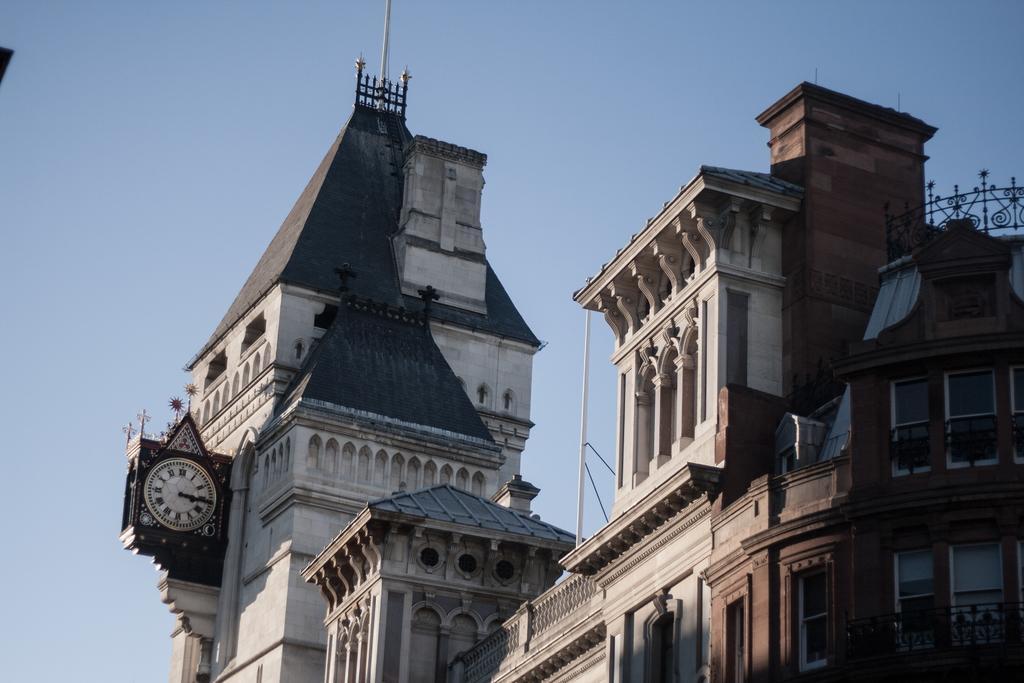Please provide a concise description of this image. In this image in front there are buildings. There is a clock on the wall. In the background of the image there is sky. 